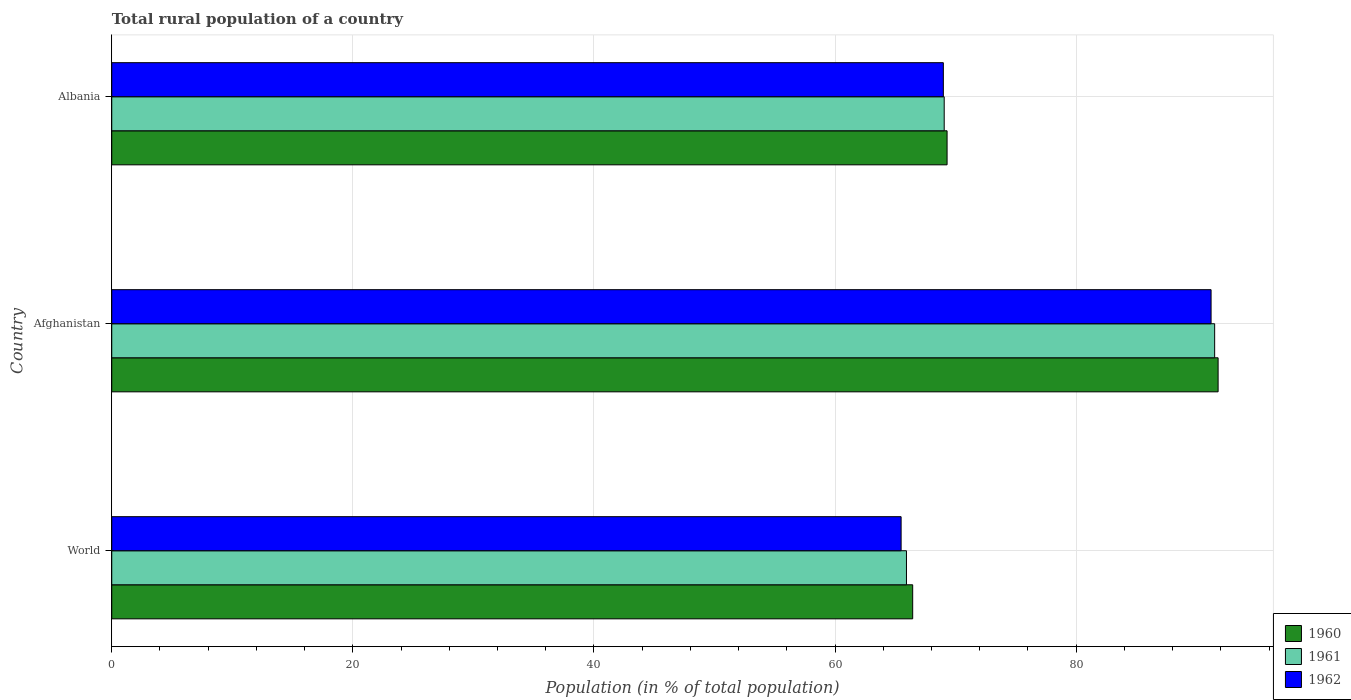How many different coloured bars are there?
Make the answer very short. 3. How many groups of bars are there?
Offer a very short reply. 3. Are the number of bars per tick equal to the number of legend labels?
Your response must be concise. Yes. Are the number of bars on each tick of the Y-axis equal?
Give a very brief answer. Yes. How many bars are there on the 2nd tick from the top?
Your response must be concise. 3. How many bars are there on the 1st tick from the bottom?
Keep it short and to the point. 3. In how many cases, is the number of bars for a given country not equal to the number of legend labels?
Provide a short and direct response. 0. What is the rural population in 1960 in Afghanistan?
Your answer should be compact. 91.78. Across all countries, what is the maximum rural population in 1961?
Your response must be concise. 91.49. Across all countries, what is the minimum rural population in 1960?
Keep it short and to the point. 66.44. In which country was the rural population in 1962 maximum?
Your answer should be compact. Afghanistan. In which country was the rural population in 1961 minimum?
Offer a very short reply. World. What is the total rural population in 1961 in the graph?
Offer a very short reply. 226.48. What is the difference between the rural population in 1960 in Afghanistan and that in Albania?
Provide a short and direct response. 22.48. What is the difference between the rural population in 1962 in Albania and the rural population in 1961 in Afghanistan?
Offer a very short reply. -22.51. What is the average rural population in 1960 per country?
Offer a terse response. 75.84. What is the difference between the rural population in 1961 and rural population in 1962 in Albania?
Give a very brief answer. 0.07. What is the ratio of the rural population in 1962 in Albania to that in World?
Keep it short and to the point. 1.05. Is the difference between the rural population in 1961 in Albania and World greater than the difference between the rural population in 1962 in Albania and World?
Your response must be concise. No. What is the difference between the highest and the second highest rural population in 1961?
Make the answer very short. 22.44. What is the difference between the highest and the lowest rural population in 1962?
Your answer should be very brief. 25.71. In how many countries, is the rural population in 1961 greater than the average rural population in 1961 taken over all countries?
Ensure brevity in your answer.  1. Is the sum of the rural population in 1962 in Albania and World greater than the maximum rural population in 1961 across all countries?
Offer a very short reply. Yes. What does the 1st bar from the bottom in Afghanistan represents?
Your answer should be compact. 1960. What is the difference between two consecutive major ticks on the X-axis?
Provide a succinct answer. 20. Are the values on the major ticks of X-axis written in scientific E-notation?
Ensure brevity in your answer.  No. Does the graph contain grids?
Provide a short and direct response. Yes. Where does the legend appear in the graph?
Your answer should be very brief. Bottom right. How are the legend labels stacked?
Your answer should be compact. Vertical. What is the title of the graph?
Make the answer very short. Total rural population of a country. What is the label or title of the X-axis?
Keep it short and to the point. Population (in % of total population). What is the Population (in % of total population) of 1960 in World?
Keep it short and to the point. 66.44. What is the Population (in % of total population) in 1961 in World?
Ensure brevity in your answer.  65.93. What is the Population (in % of total population) in 1962 in World?
Keep it short and to the point. 65.48. What is the Population (in % of total population) in 1960 in Afghanistan?
Give a very brief answer. 91.78. What is the Population (in % of total population) of 1961 in Afghanistan?
Provide a succinct answer. 91.49. What is the Population (in % of total population) of 1962 in Afghanistan?
Your answer should be very brief. 91.19. What is the Population (in % of total population) in 1960 in Albania?
Offer a terse response. 69.3. What is the Population (in % of total population) in 1961 in Albania?
Ensure brevity in your answer.  69.06. What is the Population (in % of total population) in 1962 in Albania?
Your answer should be very brief. 68.98. Across all countries, what is the maximum Population (in % of total population) of 1960?
Ensure brevity in your answer.  91.78. Across all countries, what is the maximum Population (in % of total population) in 1961?
Provide a short and direct response. 91.49. Across all countries, what is the maximum Population (in % of total population) of 1962?
Ensure brevity in your answer.  91.19. Across all countries, what is the minimum Population (in % of total population) of 1960?
Provide a succinct answer. 66.44. Across all countries, what is the minimum Population (in % of total population) of 1961?
Your answer should be very brief. 65.93. Across all countries, what is the minimum Population (in % of total population) of 1962?
Offer a terse response. 65.48. What is the total Population (in % of total population) of 1960 in the graph?
Offer a terse response. 227.52. What is the total Population (in % of total population) of 1961 in the graph?
Your answer should be compact. 226.48. What is the total Population (in % of total population) of 1962 in the graph?
Your answer should be very brief. 225.66. What is the difference between the Population (in % of total population) of 1960 in World and that in Afghanistan?
Your answer should be very brief. -25.34. What is the difference between the Population (in % of total population) in 1961 in World and that in Afghanistan?
Provide a succinct answer. -25.57. What is the difference between the Population (in % of total population) in 1962 in World and that in Afghanistan?
Provide a short and direct response. -25.71. What is the difference between the Population (in % of total population) in 1960 in World and that in Albania?
Your answer should be compact. -2.85. What is the difference between the Population (in % of total population) in 1961 in World and that in Albania?
Provide a short and direct response. -3.13. What is the difference between the Population (in % of total population) in 1962 in World and that in Albania?
Make the answer very short. -3.5. What is the difference between the Population (in % of total population) in 1960 in Afghanistan and that in Albania?
Your answer should be compact. 22.48. What is the difference between the Population (in % of total population) in 1961 in Afghanistan and that in Albania?
Provide a short and direct response. 22.43. What is the difference between the Population (in % of total population) in 1962 in Afghanistan and that in Albania?
Make the answer very short. 22.21. What is the difference between the Population (in % of total population) of 1960 in World and the Population (in % of total population) of 1961 in Afghanistan?
Ensure brevity in your answer.  -25.05. What is the difference between the Population (in % of total population) in 1960 in World and the Population (in % of total population) in 1962 in Afghanistan?
Your answer should be compact. -24.75. What is the difference between the Population (in % of total population) in 1961 in World and the Population (in % of total population) in 1962 in Afghanistan?
Provide a succinct answer. -25.27. What is the difference between the Population (in % of total population) in 1960 in World and the Population (in % of total population) in 1961 in Albania?
Ensure brevity in your answer.  -2.61. What is the difference between the Population (in % of total population) in 1960 in World and the Population (in % of total population) in 1962 in Albania?
Keep it short and to the point. -2.54. What is the difference between the Population (in % of total population) of 1961 in World and the Population (in % of total population) of 1962 in Albania?
Offer a very short reply. -3.06. What is the difference between the Population (in % of total population) in 1960 in Afghanistan and the Population (in % of total population) in 1961 in Albania?
Your response must be concise. 22.72. What is the difference between the Population (in % of total population) of 1960 in Afghanistan and the Population (in % of total population) of 1962 in Albania?
Give a very brief answer. 22.79. What is the difference between the Population (in % of total population) of 1961 in Afghanistan and the Population (in % of total population) of 1962 in Albania?
Ensure brevity in your answer.  22.51. What is the average Population (in % of total population) in 1960 per country?
Your response must be concise. 75.84. What is the average Population (in % of total population) in 1961 per country?
Provide a succinct answer. 75.49. What is the average Population (in % of total population) in 1962 per country?
Your answer should be very brief. 75.22. What is the difference between the Population (in % of total population) in 1960 and Population (in % of total population) in 1961 in World?
Your response must be concise. 0.52. What is the difference between the Population (in % of total population) of 1960 and Population (in % of total population) of 1962 in World?
Offer a terse response. 0.96. What is the difference between the Population (in % of total population) of 1961 and Population (in % of total population) of 1962 in World?
Ensure brevity in your answer.  0.44. What is the difference between the Population (in % of total population) in 1960 and Population (in % of total population) in 1961 in Afghanistan?
Provide a short and direct response. 0.29. What is the difference between the Population (in % of total population) in 1960 and Population (in % of total population) in 1962 in Afghanistan?
Your response must be concise. 0.58. What is the difference between the Population (in % of total population) of 1961 and Population (in % of total population) of 1962 in Afghanistan?
Provide a succinct answer. 0.3. What is the difference between the Population (in % of total population) in 1960 and Population (in % of total population) in 1961 in Albania?
Your response must be concise. 0.24. What is the difference between the Population (in % of total population) of 1960 and Population (in % of total population) of 1962 in Albania?
Give a very brief answer. 0.31. What is the difference between the Population (in % of total population) of 1961 and Population (in % of total population) of 1962 in Albania?
Offer a terse response. 0.07. What is the ratio of the Population (in % of total population) in 1960 in World to that in Afghanistan?
Make the answer very short. 0.72. What is the ratio of the Population (in % of total population) of 1961 in World to that in Afghanistan?
Make the answer very short. 0.72. What is the ratio of the Population (in % of total population) in 1962 in World to that in Afghanistan?
Offer a very short reply. 0.72. What is the ratio of the Population (in % of total population) in 1960 in World to that in Albania?
Provide a short and direct response. 0.96. What is the ratio of the Population (in % of total population) in 1961 in World to that in Albania?
Keep it short and to the point. 0.95. What is the ratio of the Population (in % of total population) in 1962 in World to that in Albania?
Offer a very short reply. 0.95. What is the ratio of the Population (in % of total population) of 1960 in Afghanistan to that in Albania?
Offer a terse response. 1.32. What is the ratio of the Population (in % of total population) of 1961 in Afghanistan to that in Albania?
Provide a succinct answer. 1.32. What is the ratio of the Population (in % of total population) in 1962 in Afghanistan to that in Albania?
Keep it short and to the point. 1.32. What is the difference between the highest and the second highest Population (in % of total population) of 1960?
Your response must be concise. 22.48. What is the difference between the highest and the second highest Population (in % of total population) of 1961?
Make the answer very short. 22.43. What is the difference between the highest and the second highest Population (in % of total population) in 1962?
Give a very brief answer. 22.21. What is the difference between the highest and the lowest Population (in % of total population) of 1960?
Your answer should be very brief. 25.34. What is the difference between the highest and the lowest Population (in % of total population) in 1961?
Your response must be concise. 25.57. What is the difference between the highest and the lowest Population (in % of total population) in 1962?
Offer a very short reply. 25.71. 